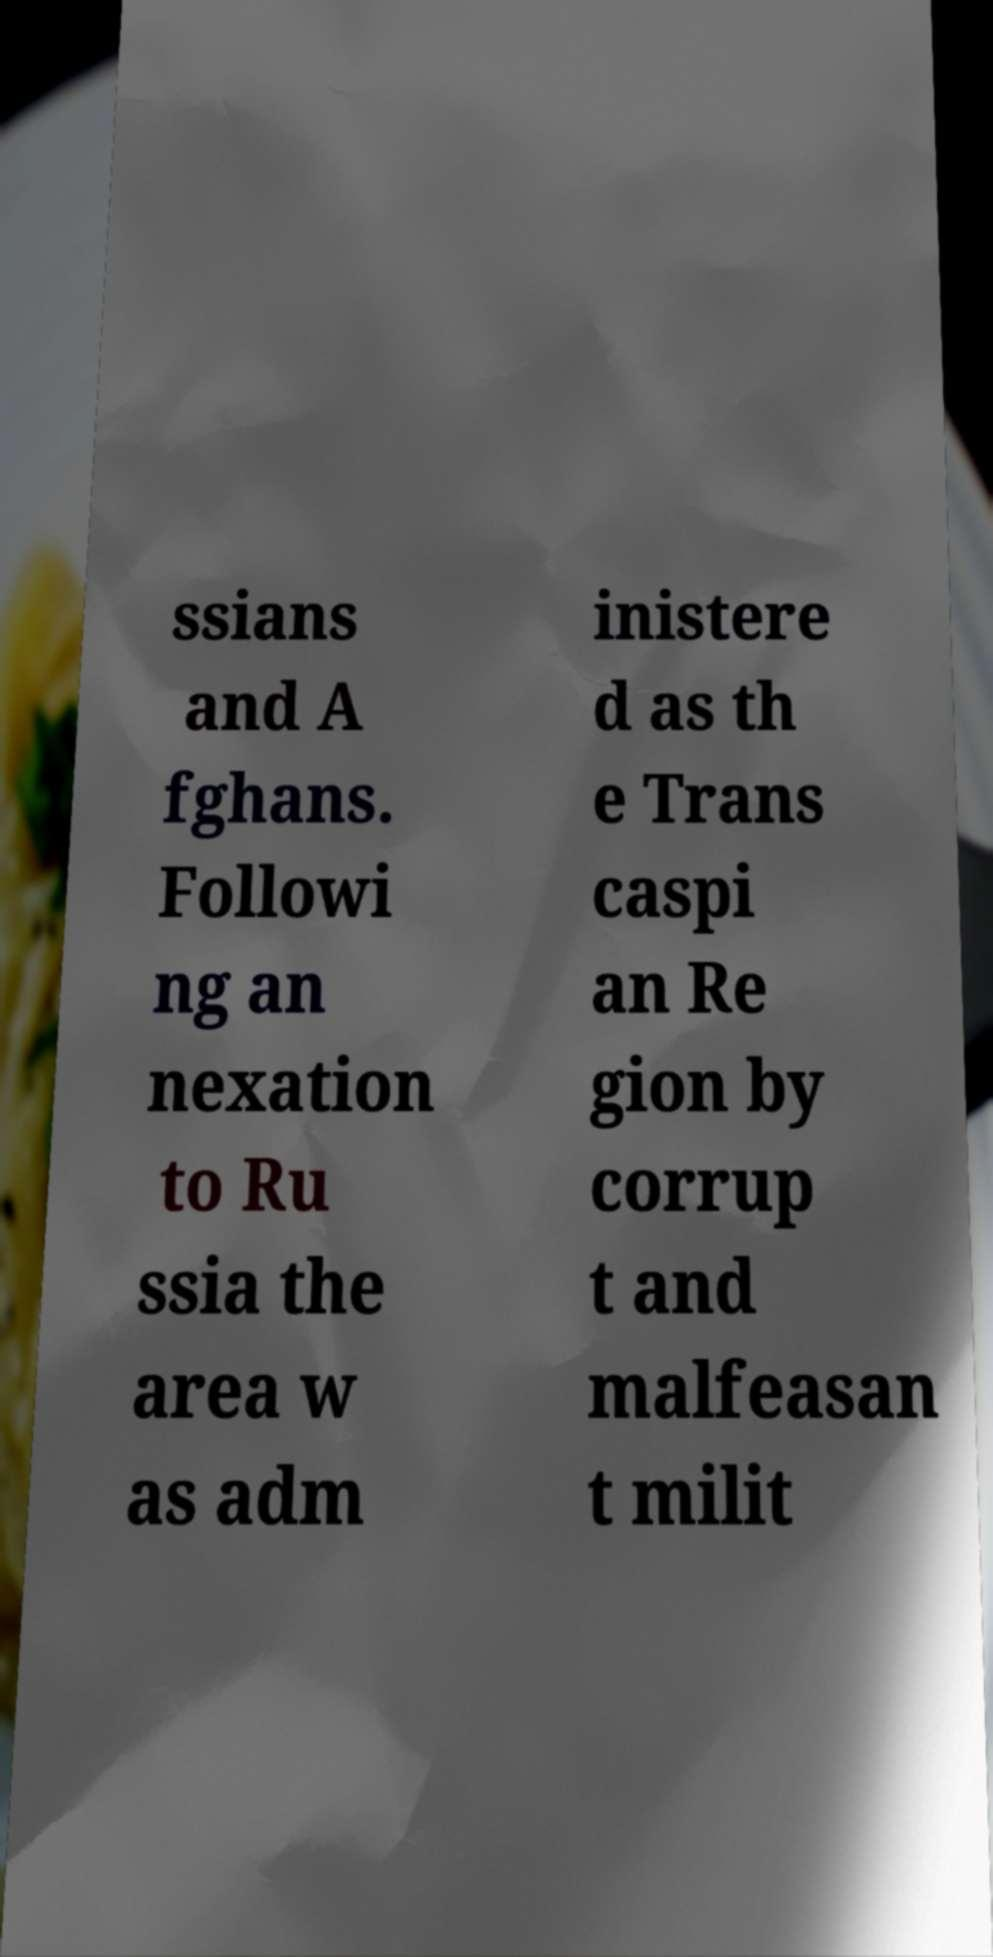What messages or text are displayed in this image? I need them in a readable, typed format. ssians and A fghans. Followi ng an nexation to Ru ssia the area w as adm inistere d as th e Trans caspi an Re gion by corrup t and malfeasan t milit 